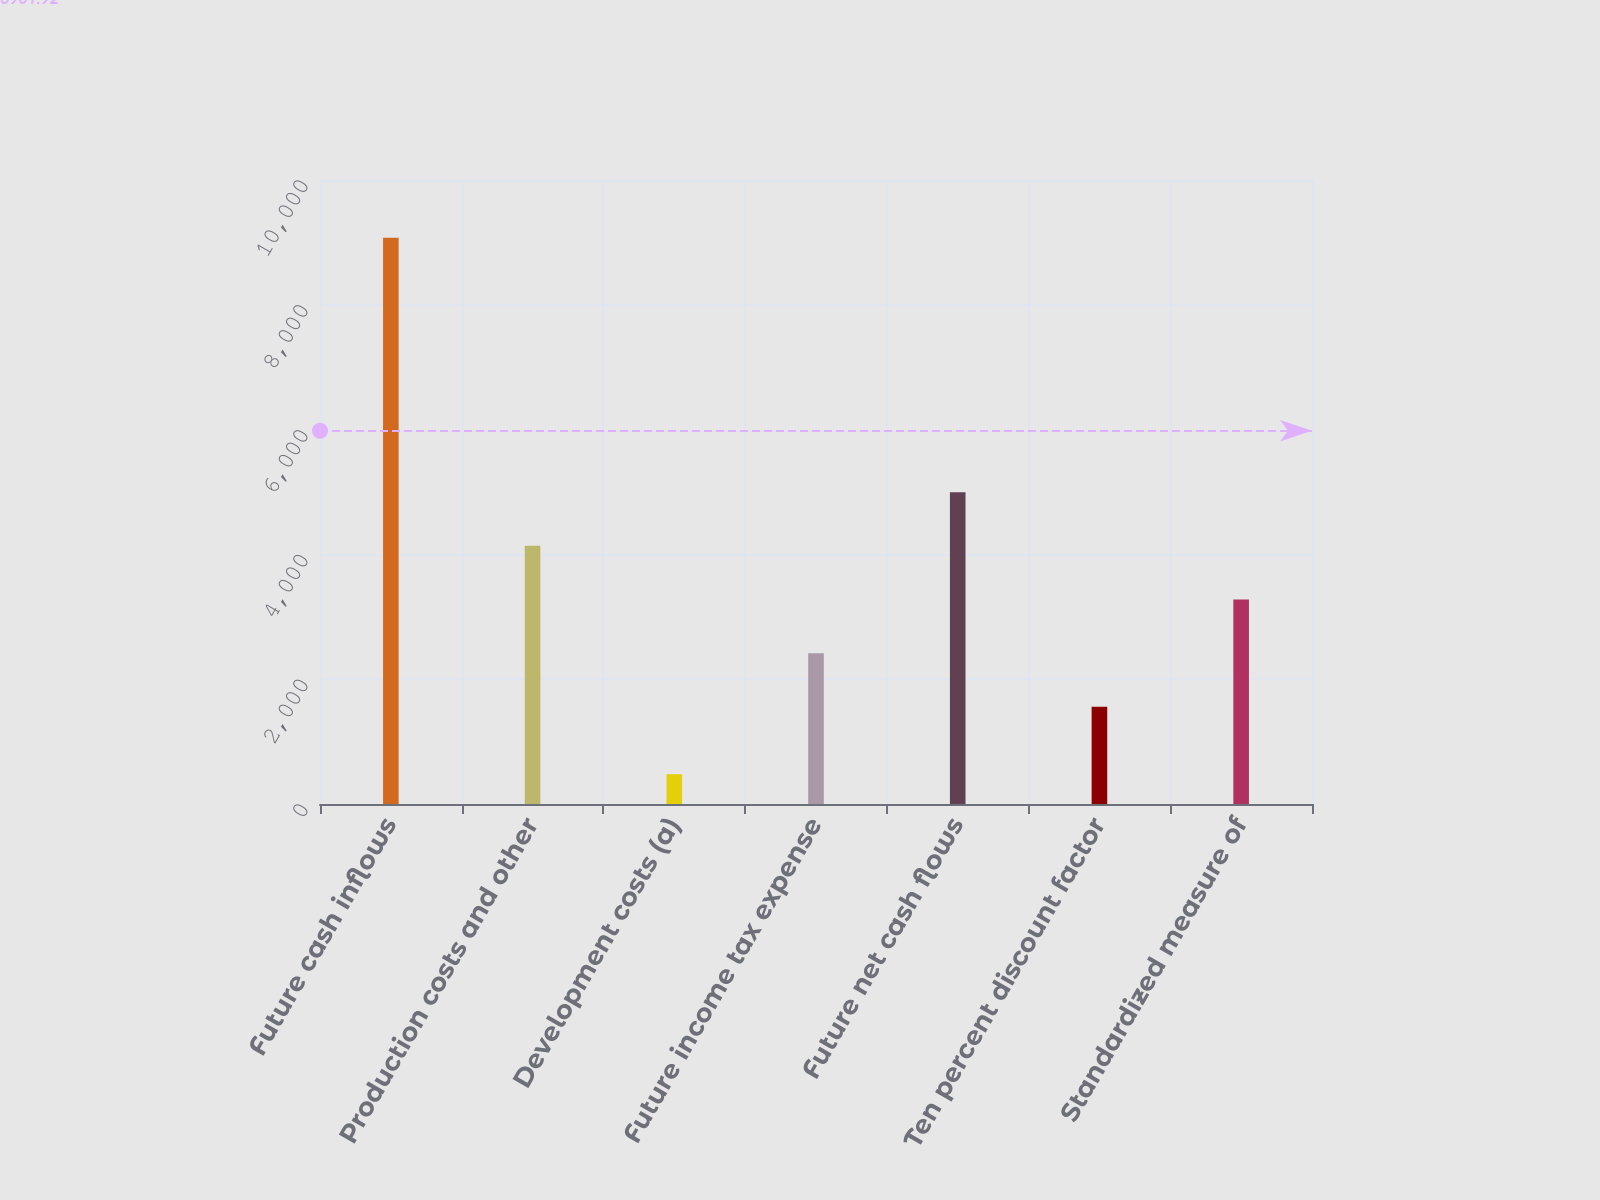<chart> <loc_0><loc_0><loc_500><loc_500><bar_chart><fcel>Future cash inflows<fcel>Production costs and other<fcel>Development costs (a)<fcel>Future income tax expense<fcel>Future net cash flows<fcel>Ten percent discount factor<fcel>Standardized measure of<nl><fcel>9076<fcel>4136.7<fcel>477<fcel>2416.9<fcel>4996.6<fcel>1557<fcel>3276.8<nl></chart> 